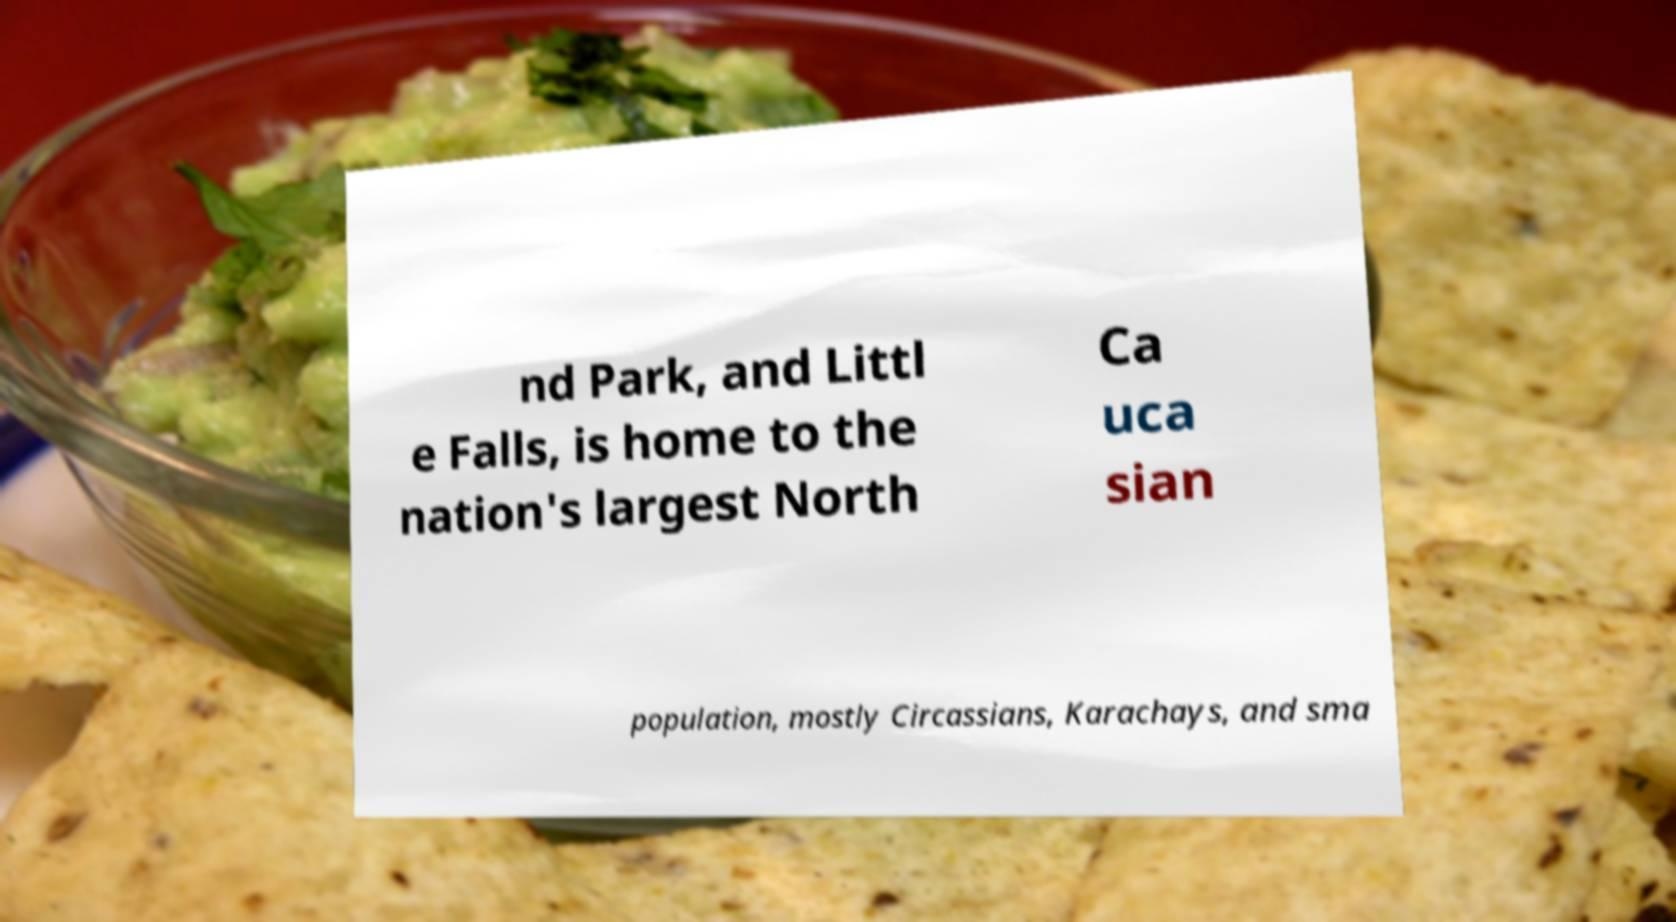Please read and relay the text visible in this image. What does it say? nd Park, and Littl e Falls, is home to the nation's largest North Ca uca sian population, mostly Circassians, Karachays, and sma 